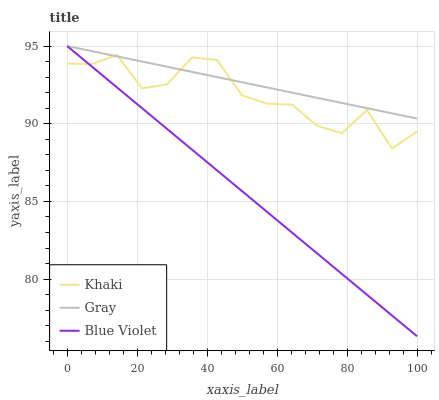Does Blue Violet have the minimum area under the curve?
Answer yes or no. Yes. Does Gray have the maximum area under the curve?
Answer yes or no. Yes. Does Khaki have the minimum area under the curve?
Answer yes or no. No. Does Khaki have the maximum area under the curve?
Answer yes or no. No. Is Blue Violet the smoothest?
Answer yes or no. Yes. Is Khaki the roughest?
Answer yes or no. Yes. Is Khaki the smoothest?
Answer yes or no. No. Is Blue Violet the roughest?
Answer yes or no. No. Does Blue Violet have the lowest value?
Answer yes or no. Yes. Does Khaki have the lowest value?
Answer yes or no. No. Does Blue Violet have the highest value?
Answer yes or no. Yes. Does Khaki have the highest value?
Answer yes or no. No. Does Blue Violet intersect Khaki?
Answer yes or no. Yes. Is Blue Violet less than Khaki?
Answer yes or no. No. Is Blue Violet greater than Khaki?
Answer yes or no. No. 